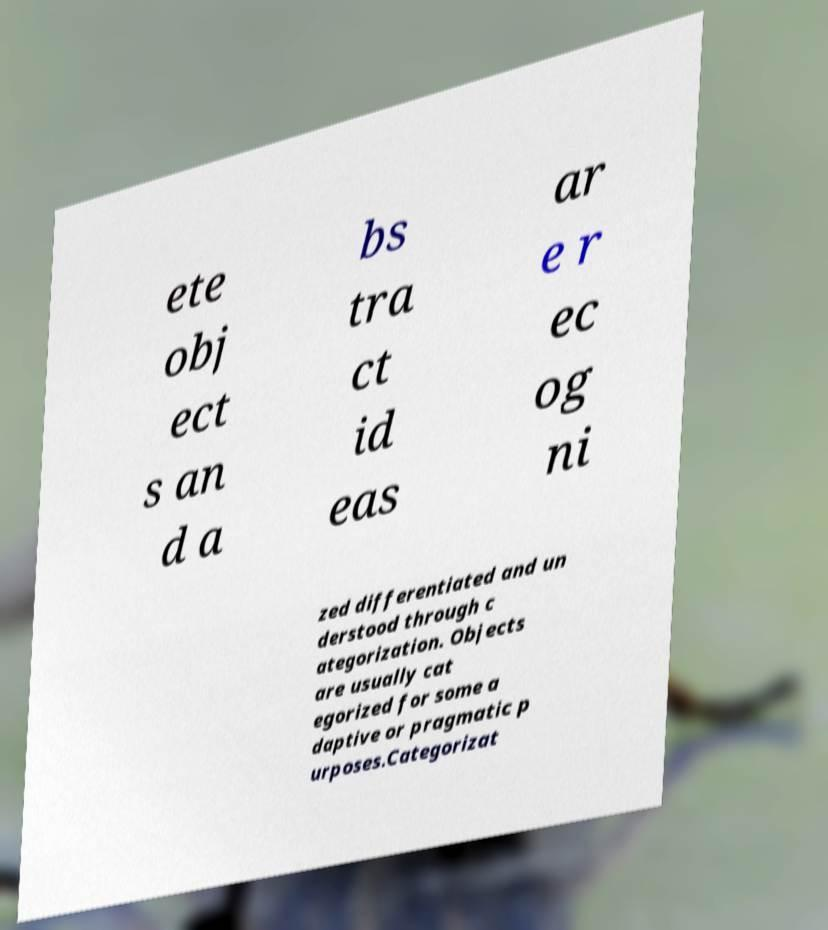There's text embedded in this image that I need extracted. Can you transcribe it verbatim? ete obj ect s an d a bs tra ct id eas ar e r ec og ni zed differentiated and un derstood through c ategorization. Objects are usually cat egorized for some a daptive or pragmatic p urposes.Categorizat 